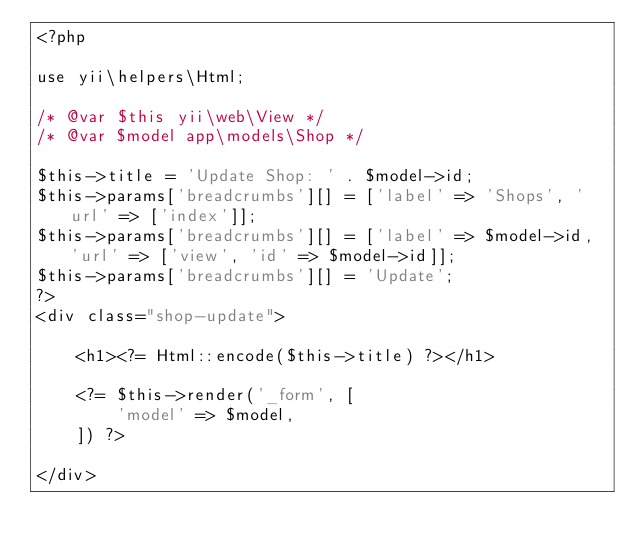<code> <loc_0><loc_0><loc_500><loc_500><_PHP_><?php

use yii\helpers\Html;

/* @var $this yii\web\View */
/* @var $model app\models\Shop */

$this->title = 'Update Shop: ' . $model->id;
$this->params['breadcrumbs'][] = ['label' => 'Shops', 'url' => ['index']];
$this->params['breadcrumbs'][] = ['label' => $model->id, 'url' => ['view', 'id' => $model->id]];
$this->params['breadcrumbs'][] = 'Update';
?>
<div class="shop-update">

    <h1><?= Html::encode($this->title) ?></h1>

    <?= $this->render('_form', [
        'model' => $model,
    ]) ?>

</div>
</code> 